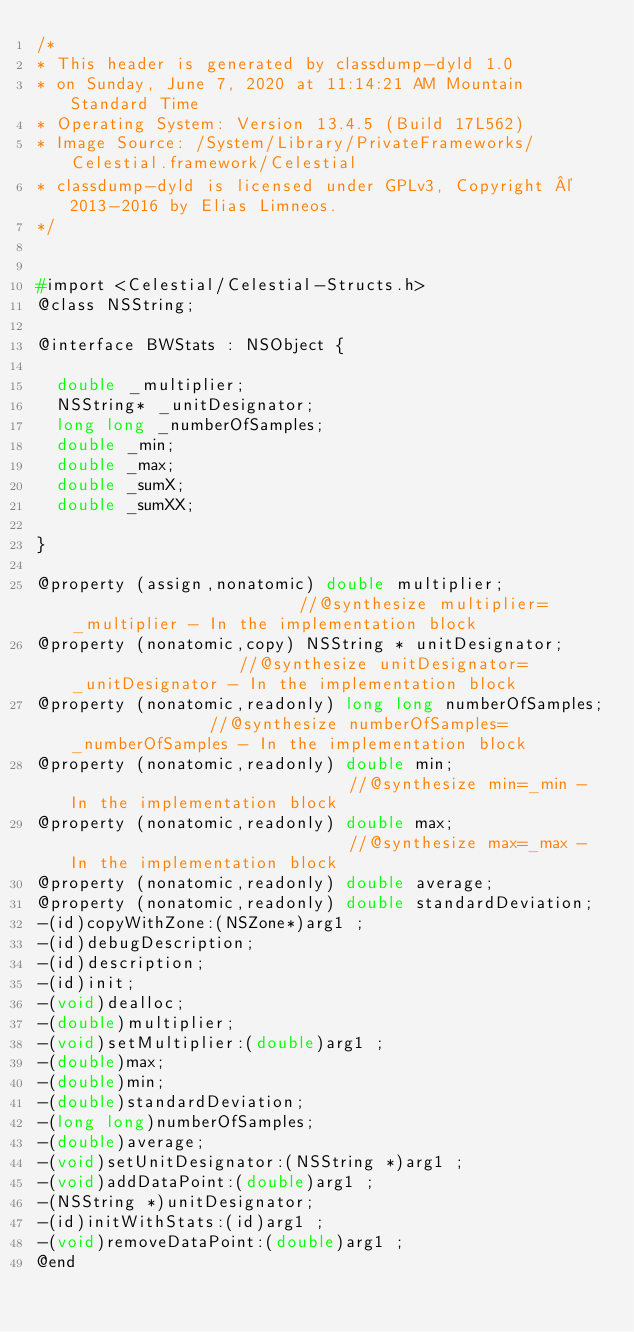Convert code to text. <code><loc_0><loc_0><loc_500><loc_500><_C_>/*
* This header is generated by classdump-dyld 1.0
* on Sunday, June 7, 2020 at 11:14:21 AM Mountain Standard Time
* Operating System: Version 13.4.5 (Build 17L562)
* Image Source: /System/Library/PrivateFrameworks/Celestial.framework/Celestial
* classdump-dyld is licensed under GPLv3, Copyright © 2013-2016 by Elias Limneos.
*/


#import <Celestial/Celestial-Structs.h>
@class NSString;

@interface BWStats : NSObject {

	double _multiplier;
	NSString* _unitDesignator;
	long long _numberOfSamples;
	double _min;
	double _max;
	double _sumX;
	double _sumXX;

}

@property (assign,nonatomic) double multiplier;                        //@synthesize multiplier=_multiplier - In the implementation block
@property (nonatomic,copy) NSString * unitDesignator;                  //@synthesize unitDesignator=_unitDesignator - In the implementation block
@property (nonatomic,readonly) long long numberOfSamples;              //@synthesize numberOfSamples=_numberOfSamples - In the implementation block
@property (nonatomic,readonly) double min;                             //@synthesize min=_min - In the implementation block
@property (nonatomic,readonly) double max;                             //@synthesize max=_max - In the implementation block
@property (nonatomic,readonly) double average; 
@property (nonatomic,readonly) double standardDeviation; 
-(id)copyWithZone:(NSZone*)arg1 ;
-(id)debugDescription;
-(id)description;
-(id)init;
-(void)dealloc;
-(double)multiplier;
-(void)setMultiplier:(double)arg1 ;
-(double)max;
-(double)min;
-(double)standardDeviation;
-(long long)numberOfSamples;
-(double)average;
-(void)setUnitDesignator:(NSString *)arg1 ;
-(void)addDataPoint:(double)arg1 ;
-(NSString *)unitDesignator;
-(id)initWithStats:(id)arg1 ;
-(void)removeDataPoint:(double)arg1 ;
@end

</code> 